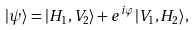Convert formula to latex. <formula><loc_0><loc_0><loc_500><loc_500>| \psi \rangle = | H _ { 1 } , V _ { 2 } \rangle + e ^ { i \varphi } | V _ { 1 } , H _ { 2 } \rangle ,</formula> 